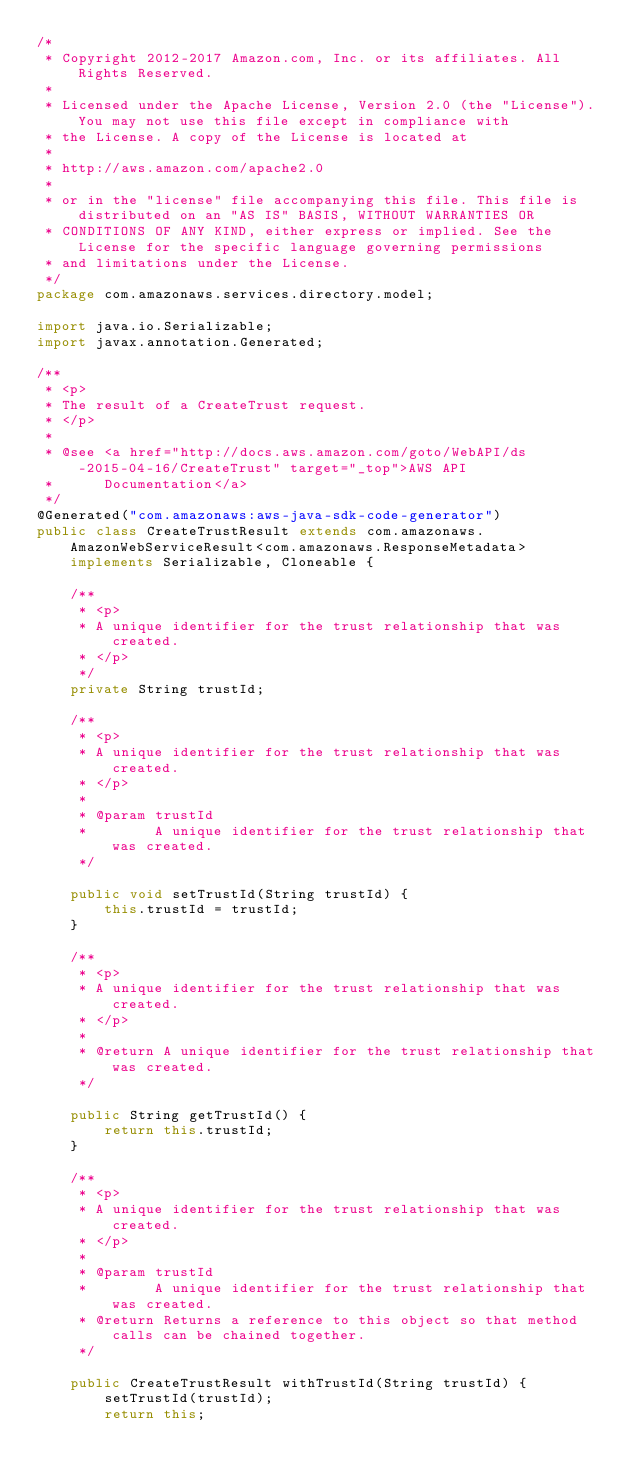Convert code to text. <code><loc_0><loc_0><loc_500><loc_500><_Java_>/*
 * Copyright 2012-2017 Amazon.com, Inc. or its affiliates. All Rights Reserved.
 * 
 * Licensed under the Apache License, Version 2.0 (the "License"). You may not use this file except in compliance with
 * the License. A copy of the License is located at
 * 
 * http://aws.amazon.com/apache2.0
 * 
 * or in the "license" file accompanying this file. This file is distributed on an "AS IS" BASIS, WITHOUT WARRANTIES OR
 * CONDITIONS OF ANY KIND, either express or implied. See the License for the specific language governing permissions
 * and limitations under the License.
 */
package com.amazonaws.services.directory.model;

import java.io.Serializable;
import javax.annotation.Generated;

/**
 * <p>
 * The result of a CreateTrust request.
 * </p>
 * 
 * @see <a href="http://docs.aws.amazon.com/goto/WebAPI/ds-2015-04-16/CreateTrust" target="_top">AWS API
 *      Documentation</a>
 */
@Generated("com.amazonaws:aws-java-sdk-code-generator")
public class CreateTrustResult extends com.amazonaws.AmazonWebServiceResult<com.amazonaws.ResponseMetadata> implements Serializable, Cloneable {

    /**
     * <p>
     * A unique identifier for the trust relationship that was created.
     * </p>
     */
    private String trustId;

    /**
     * <p>
     * A unique identifier for the trust relationship that was created.
     * </p>
     * 
     * @param trustId
     *        A unique identifier for the trust relationship that was created.
     */

    public void setTrustId(String trustId) {
        this.trustId = trustId;
    }

    /**
     * <p>
     * A unique identifier for the trust relationship that was created.
     * </p>
     * 
     * @return A unique identifier for the trust relationship that was created.
     */

    public String getTrustId() {
        return this.trustId;
    }

    /**
     * <p>
     * A unique identifier for the trust relationship that was created.
     * </p>
     * 
     * @param trustId
     *        A unique identifier for the trust relationship that was created.
     * @return Returns a reference to this object so that method calls can be chained together.
     */

    public CreateTrustResult withTrustId(String trustId) {
        setTrustId(trustId);
        return this;</code> 